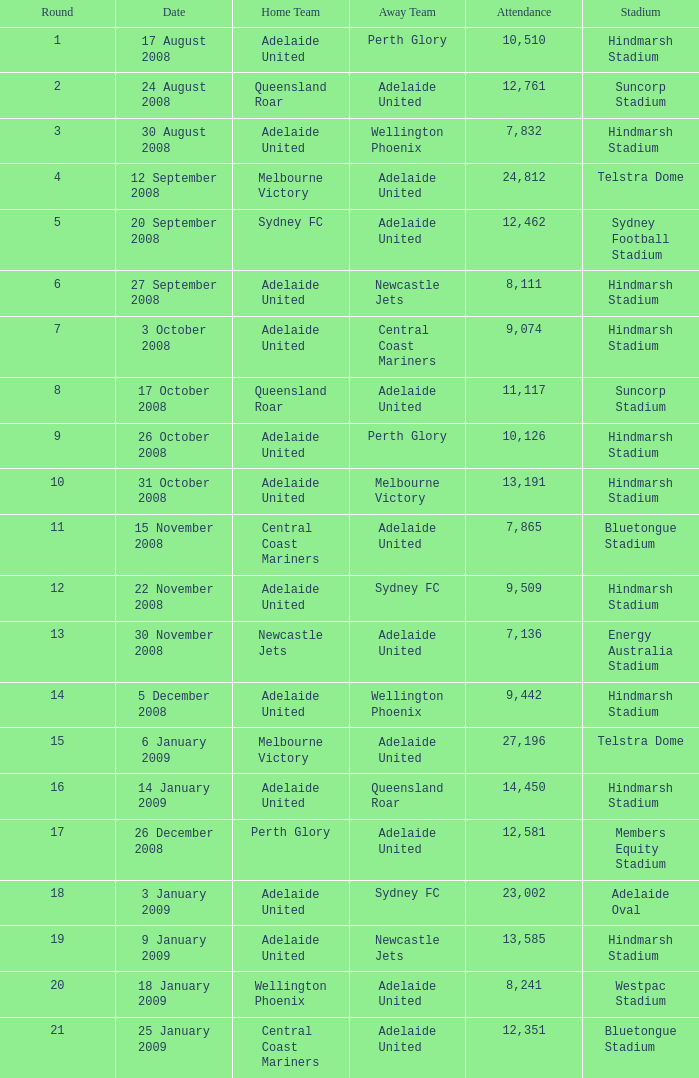Who was the away team when Queensland Roar was the home team in the round less than 3? Adelaide United. 